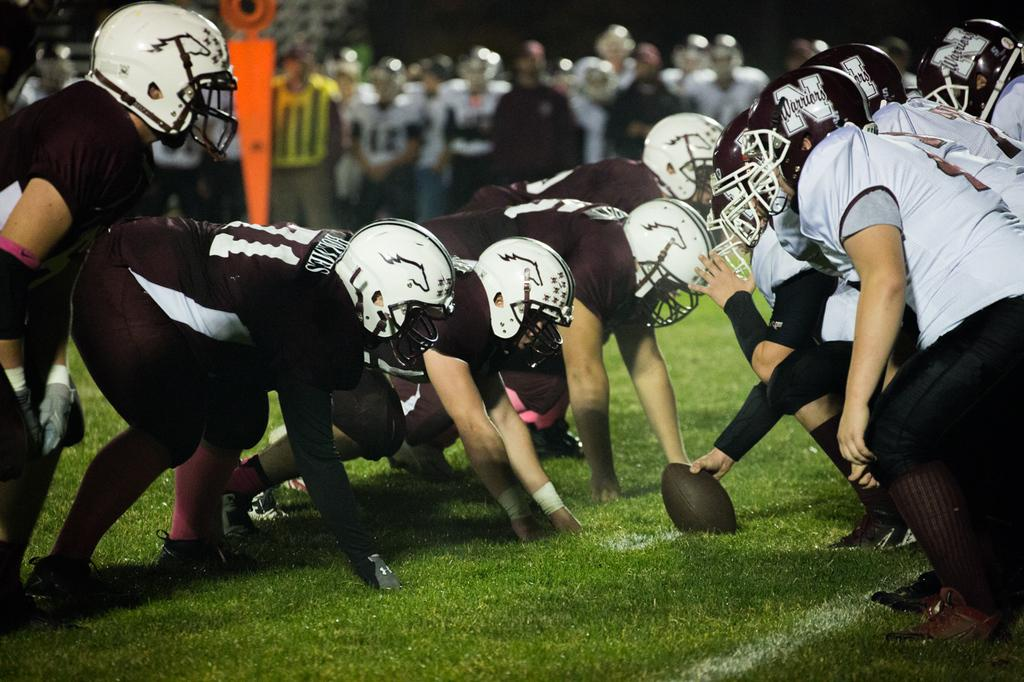What sport are the persons playing in the image? The persons are playing rugby in the image. What colors are the t-shirts worn by the players? The players are wearing thick brown and gray color t-shirts. On what surface is the rugby being played? The rugby is being played on the grass. Are there any other people visible in the image besides the rugby players? Yes, there are persons visible in the background of the image. How would you describe the background of the image? The background is blurred. What type of injury is the man receiving treatment for in the image? There is no man receiving treatment in the image; it is a rugby game being played on the grass. Is there a hospital visible in the background of the image? No, there is no hospital visible in the image; the background is blurred and only shows other persons. 